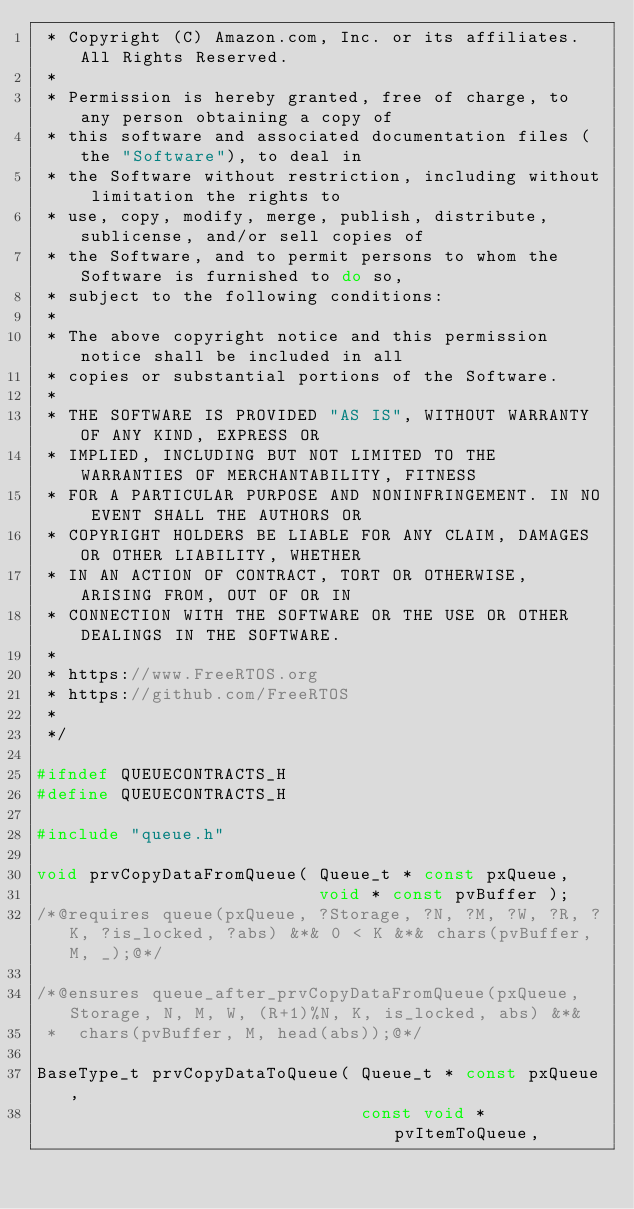<code> <loc_0><loc_0><loc_500><loc_500><_C_> * Copyright (C) Amazon.com, Inc. or its affiliates.  All Rights Reserved.
 *
 * Permission is hereby granted, free of charge, to any person obtaining a copy of
 * this software and associated documentation files (the "Software"), to deal in
 * the Software without restriction, including without limitation the rights to
 * use, copy, modify, merge, publish, distribute, sublicense, and/or sell copies of
 * the Software, and to permit persons to whom the Software is furnished to do so,
 * subject to the following conditions:
 *
 * The above copyright notice and this permission notice shall be included in all
 * copies or substantial portions of the Software.
 *
 * THE SOFTWARE IS PROVIDED "AS IS", WITHOUT WARRANTY OF ANY KIND, EXPRESS OR
 * IMPLIED, INCLUDING BUT NOT LIMITED TO THE WARRANTIES OF MERCHANTABILITY, FITNESS
 * FOR A PARTICULAR PURPOSE AND NONINFRINGEMENT. IN NO EVENT SHALL THE AUTHORS OR
 * COPYRIGHT HOLDERS BE LIABLE FOR ANY CLAIM, DAMAGES OR OTHER LIABILITY, WHETHER
 * IN AN ACTION OF CONTRACT, TORT OR OTHERWISE, ARISING FROM, OUT OF OR IN
 * CONNECTION WITH THE SOFTWARE OR THE USE OR OTHER DEALINGS IN THE SOFTWARE.
 *
 * https://www.FreeRTOS.org
 * https://github.com/FreeRTOS
 *
 */

#ifndef QUEUECONTRACTS_H
#define QUEUECONTRACTS_H

#include "queue.h"

void prvCopyDataFromQueue( Queue_t * const pxQueue,
                           void * const pvBuffer );
/*@requires queue(pxQueue, ?Storage, ?N, ?M, ?W, ?R, ?K, ?is_locked, ?abs) &*& 0 < K &*& chars(pvBuffer, M, _);@*/

/*@ensures queue_after_prvCopyDataFromQueue(pxQueue, Storage, N, M, W, (R+1)%N, K, is_locked, abs) &*&
 *  chars(pvBuffer, M, head(abs));@*/

BaseType_t prvCopyDataToQueue( Queue_t * const pxQueue,
                               const void * pvItemToQueue,</code> 